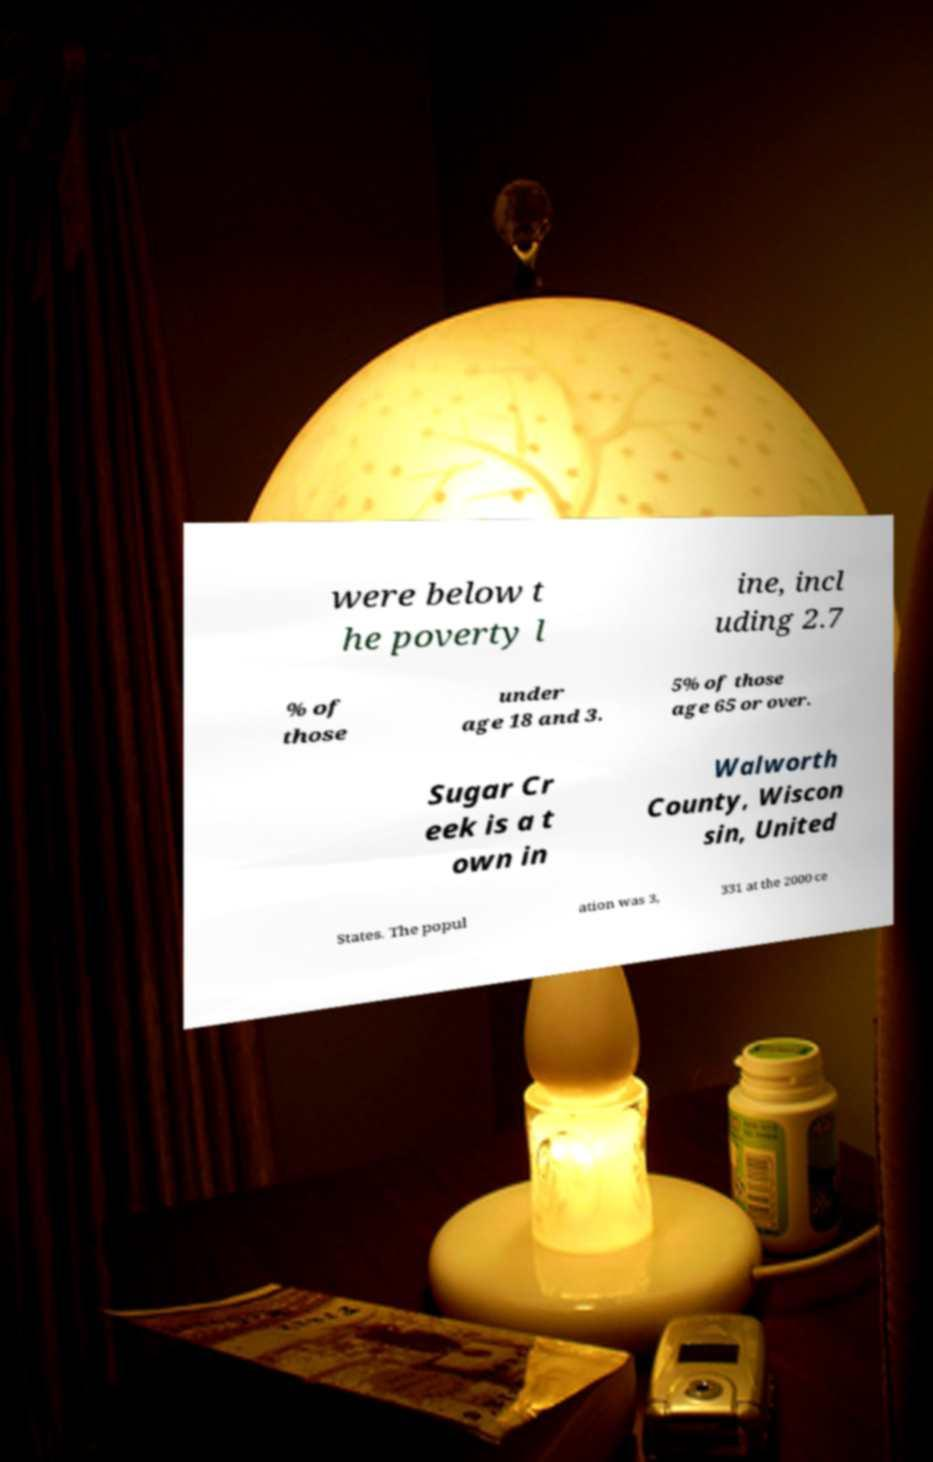Could you extract and type out the text from this image? were below t he poverty l ine, incl uding 2.7 % of those under age 18 and 3. 5% of those age 65 or over. Sugar Cr eek is a t own in Walworth County, Wiscon sin, United States. The popul ation was 3, 331 at the 2000 ce 